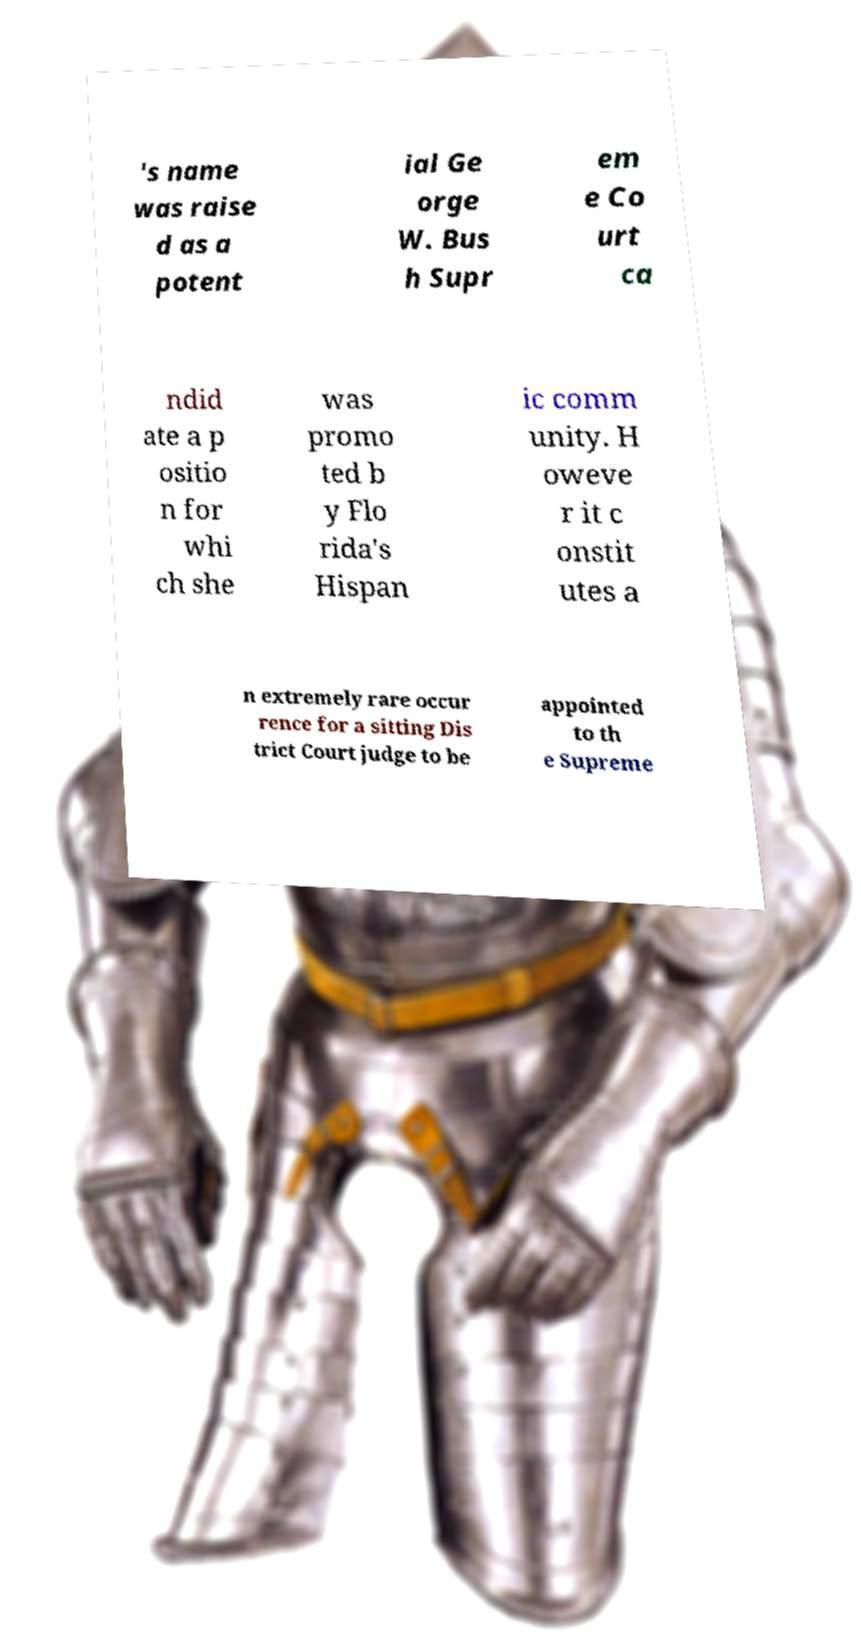I need the written content from this picture converted into text. Can you do that? 's name was raise d as a potent ial Ge orge W. Bus h Supr em e Co urt ca ndid ate a p ositio n for whi ch she was promo ted b y Flo rida's Hispan ic comm unity. H oweve r it c onstit utes a n extremely rare occur rence for a sitting Dis trict Court judge to be appointed to th e Supreme 